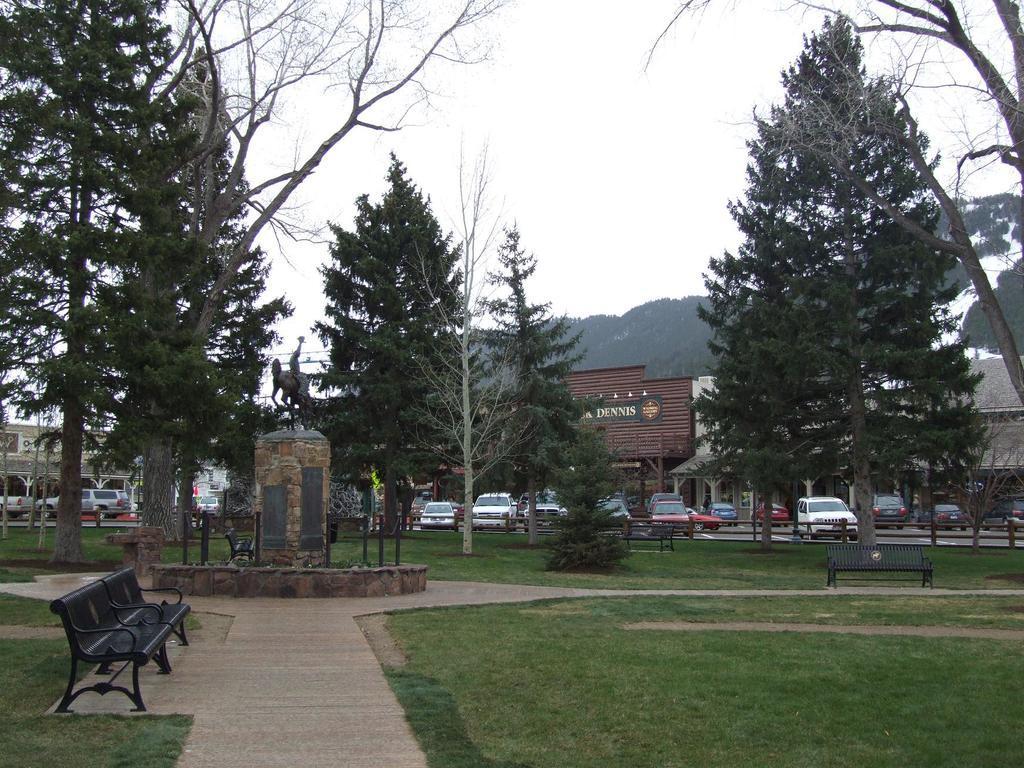Can you describe this image briefly? In this picture I can see the grass in front, on which there are benches and few trees and I can also see a statue in the center and in the middle of this picture I see number of buildings and number of cars. In the background I see the sky. 